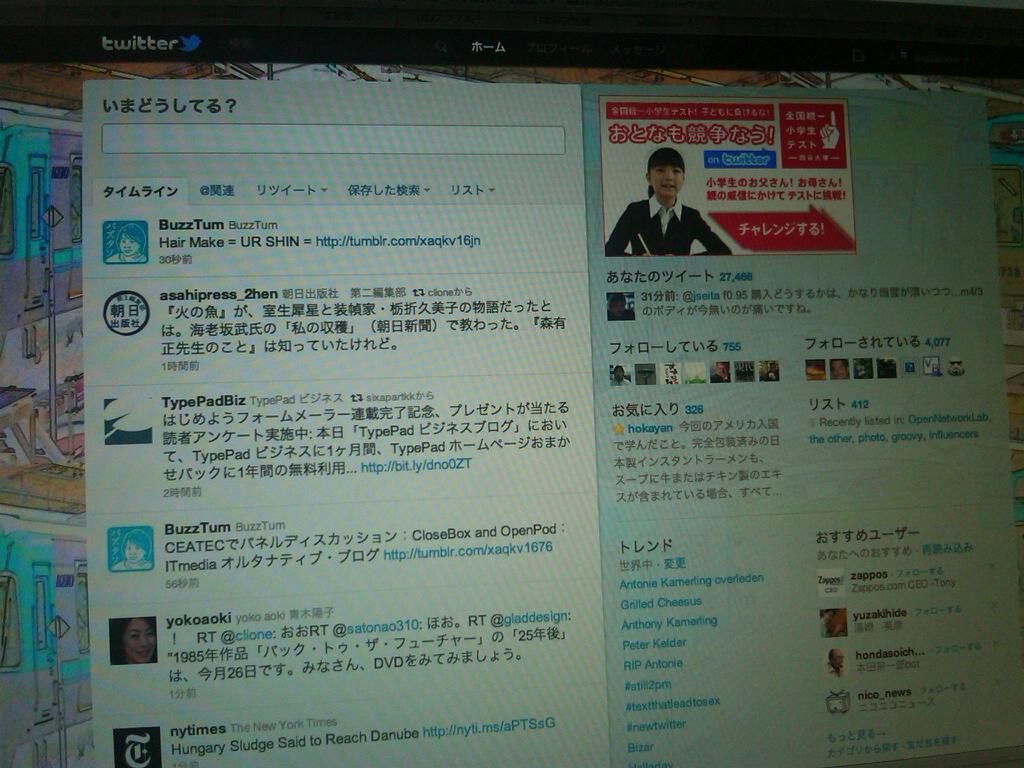<image>
Summarize the visual content of the image. A twitter webpage that has Asian text and several hashtags including grilled cheese and Peter Kelder. 